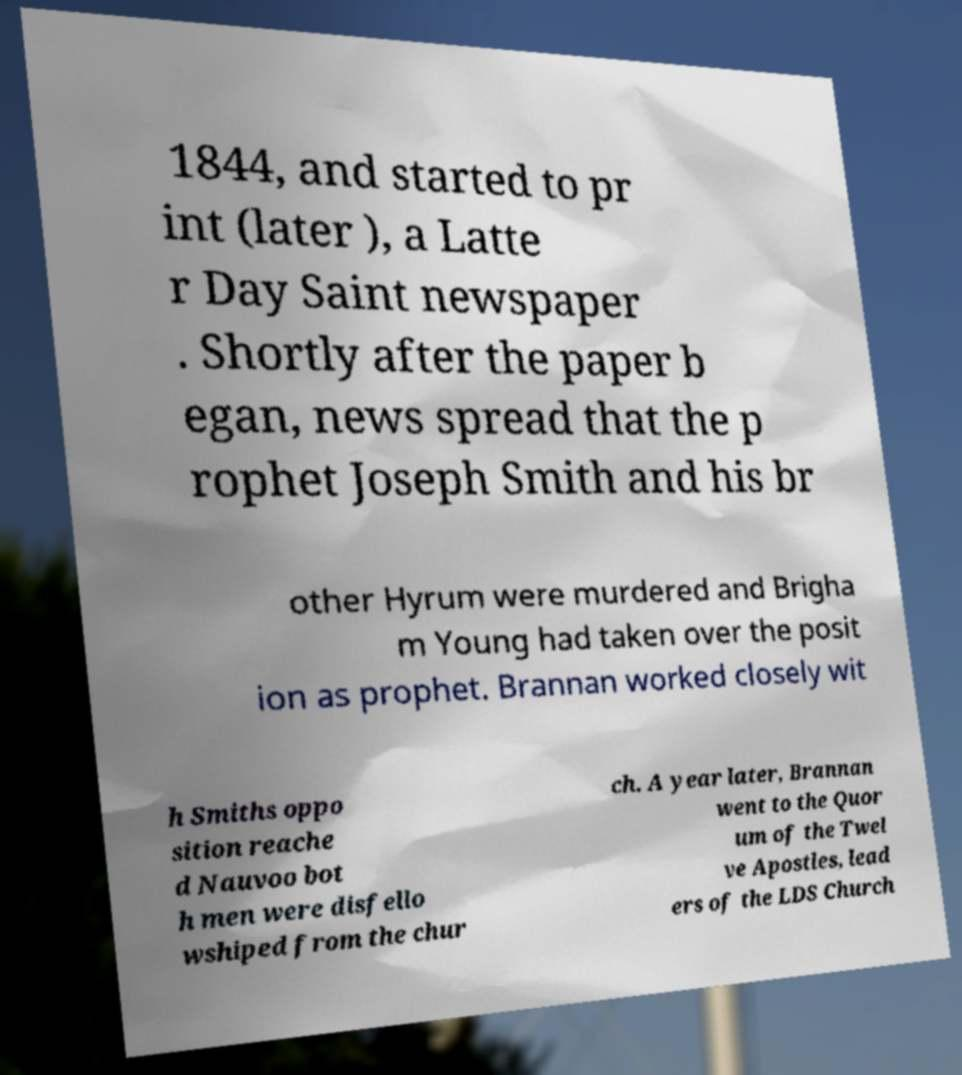There's text embedded in this image that I need extracted. Can you transcribe it verbatim? 1844, and started to pr int (later ), a Latte r Day Saint newspaper . Shortly after the paper b egan, news spread that the p rophet Joseph Smith and his br other Hyrum were murdered and Brigha m Young had taken over the posit ion as prophet. Brannan worked closely wit h Smiths oppo sition reache d Nauvoo bot h men were disfello wshiped from the chur ch. A year later, Brannan went to the Quor um of the Twel ve Apostles, lead ers of the LDS Church 